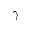<formula> <loc_0><loc_0><loc_500><loc_500>\gamma</formula> 